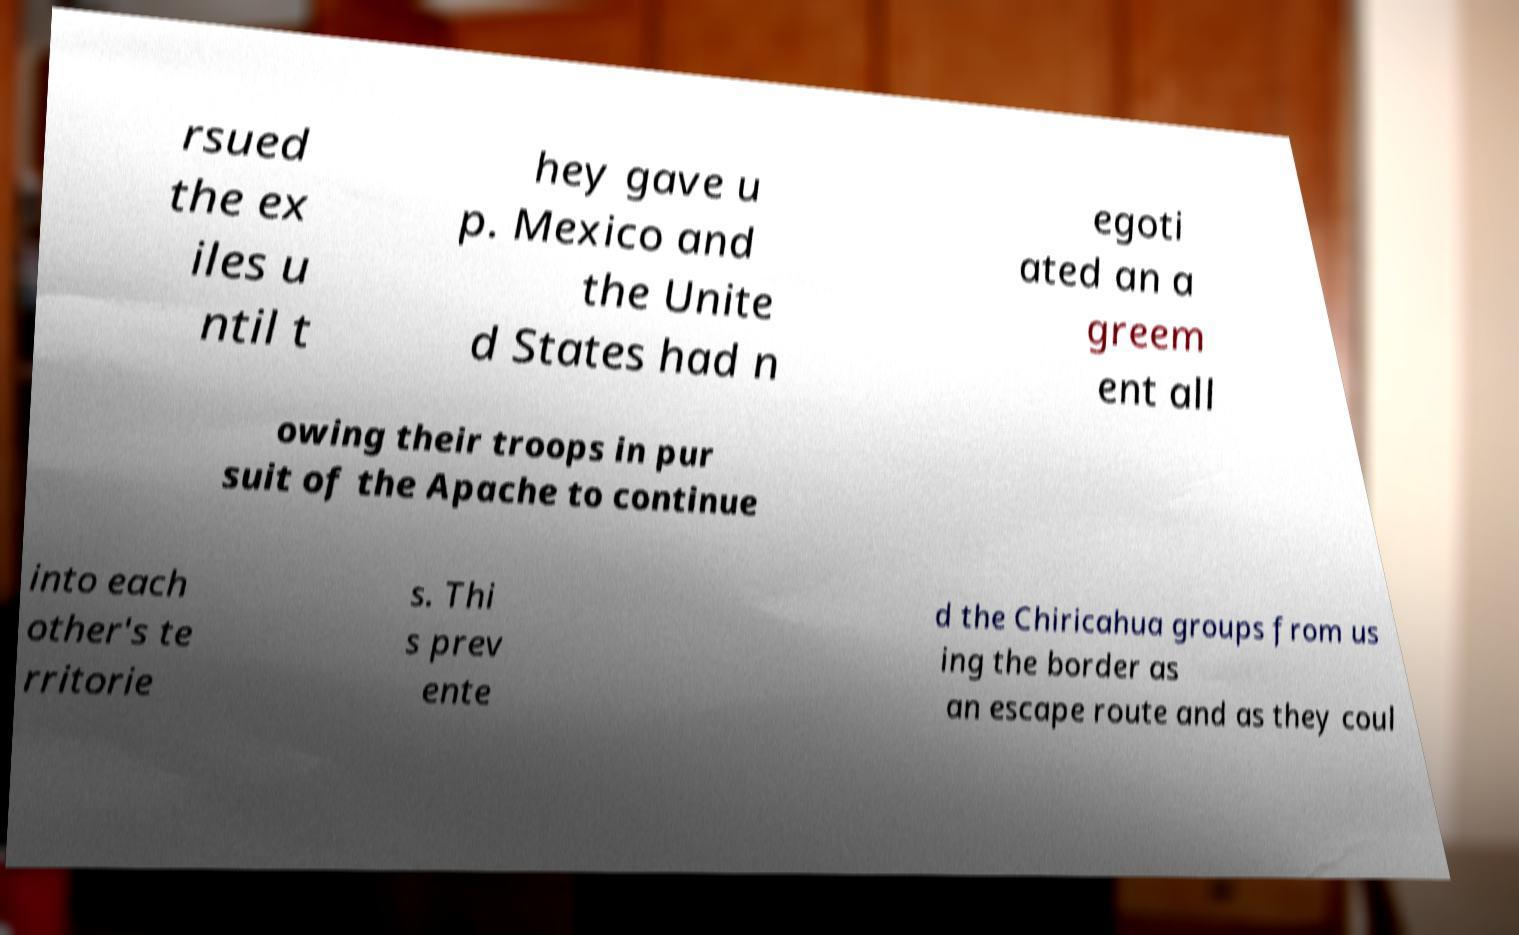For documentation purposes, I need the text within this image transcribed. Could you provide that? rsued the ex iles u ntil t hey gave u p. Mexico and the Unite d States had n egoti ated an a greem ent all owing their troops in pur suit of the Apache to continue into each other's te rritorie s. Thi s prev ente d the Chiricahua groups from us ing the border as an escape route and as they coul 